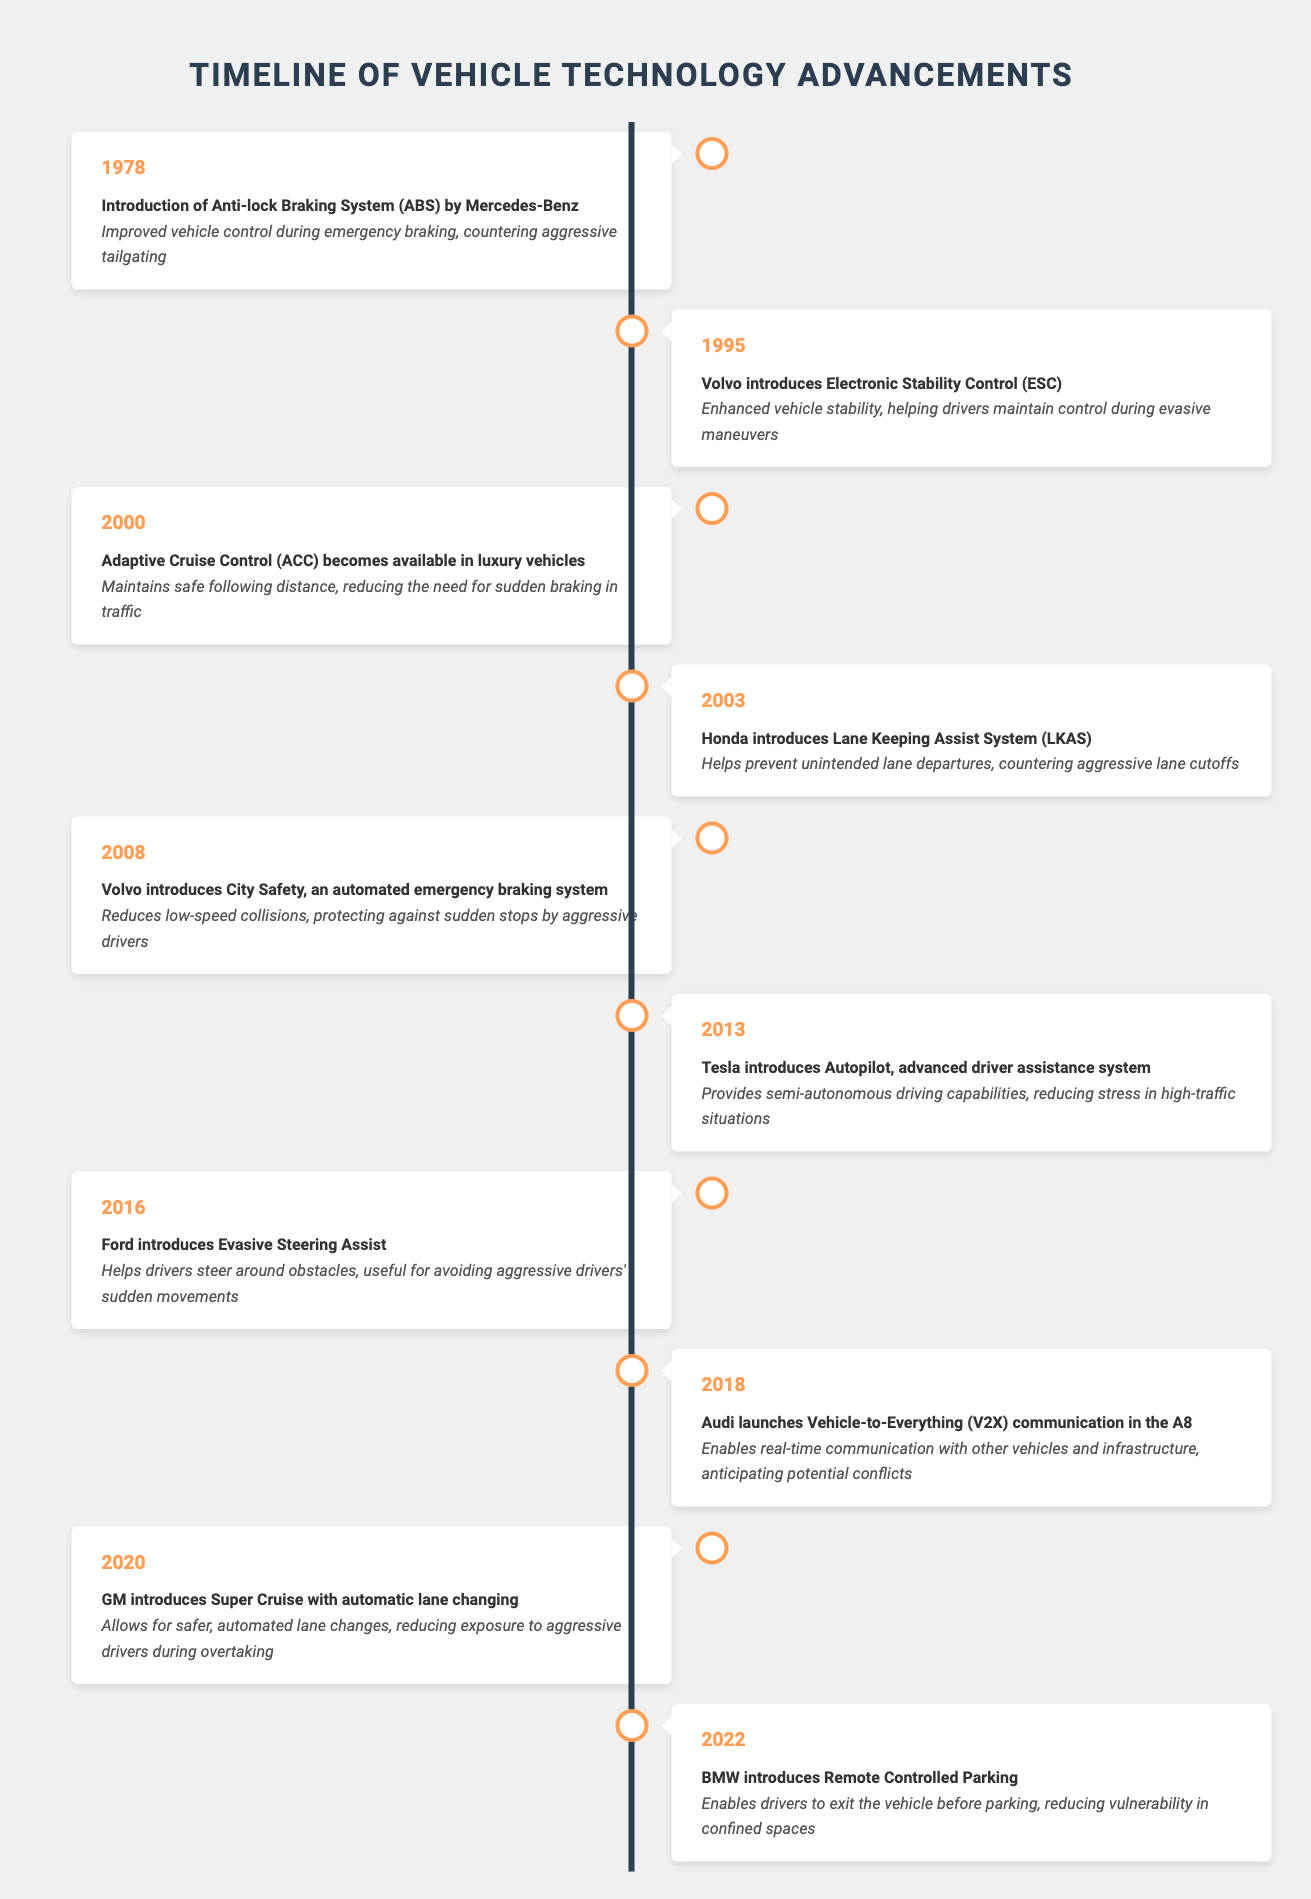What year did BMW introduce Remote Controlled Parking? The table shows that BMW introduced Remote Controlled Parking in the year 2022.
Answer: 2022 What impact did the introduction of Electronic Stability Control (ESC) have? According to the table, the introduction of ESC by Volvo in 1995 enhanced vehicle stability, helping drivers maintain control during evasive maneuvers.
Answer: Enhanced vehicle stability Which technological advancement in vehicle technology was introduced in 2000? The timeline indicates that Adaptive Cruise Control (ACC) became available in luxury vehicles in 2000.
Answer: Adaptive Cruise Control True or False: The introduction of City Safety by Volvo in 2008 reduced low-speed collisions. The table clearly states that the introduction of City Safety, an automated emergency braking system by Volvo in 2008, was designed to reduce low-speed collisions. Therefore, the statement is true.
Answer: True What is the difference between the advancements made in 1978 and 2018 in terms of aggressive driving technology? In 1978, the Anti-lock Braking System (ABS) was introduced, improving vehicle control during emergency braking. In 2018, Vehicle-to-Everything (V2X) communication was launched, enabling real-time communication with other vehicles and infrastructure to anticipate potential conflicts. The advancements reflect a shift from purely mechanical control improvements to technological integration for communication and collaboration in traffic.
Answer: Shift from mechanical to communication-based technology What is the total number of advancements mentioned in the timeline? The table lists a total of 10 different advancements in vehicle technology from 1978 to 2022.
Answer: 10 How many of the advancements were introduced before 2010? From the timeline, we see that the following advancements were introduced before 2010: ABS (1978), ESC (1995), ACC (2000), LKAS (2003), City Safety (2008). This makes a total of 5 advancements before 2010.
Answer: 5 